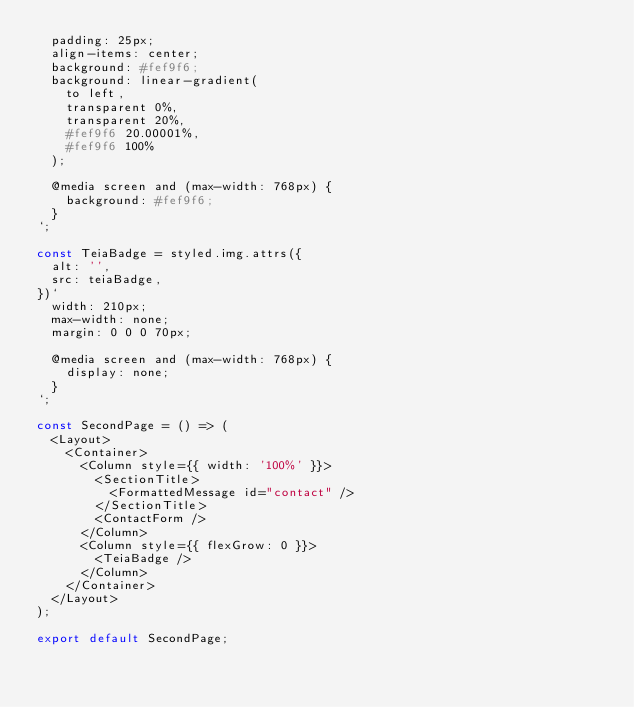<code> <loc_0><loc_0><loc_500><loc_500><_JavaScript_>  padding: 25px;
  align-items: center;
  background: #fef9f6;
  background: linear-gradient(
    to left,
    transparent 0%,
    transparent 20%,
    #fef9f6 20.00001%,
    #fef9f6 100%
  );

  @media screen and (max-width: 768px) {
    background: #fef9f6;
  }
`;

const TeiaBadge = styled.img.attrs({
  alt: '',
  src: teiaBadge,
})`
  width: 210px;
  max-width: none;
  margin: 0 0 0 70px;

  @media screen and (max-width: 768px) {
    display: none;
  }
`;

const SecondPage = () => (
  <Layout>
    <Container>
      <Column style={{ width: '100%' }}>
        <SectionTitle>
          <FormattedMessage id="contact" />
        </SectionTitle>
        <ContactForm />
      </Column>
      <Column style={{ flexGrow: 0 }}>
        <TeiaBadge />
      </Column>
    </Container>
  </Layout>
);

export default SecondPage;
</code> 